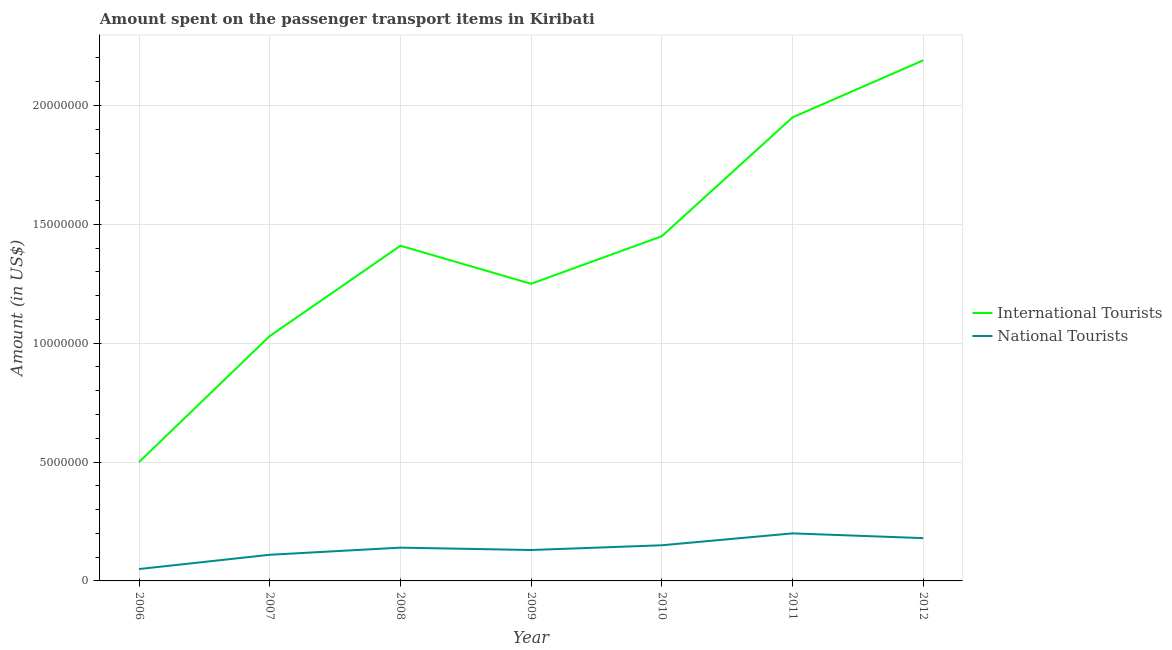What is the amount spent on transport items of international tourists in 2010?
Keep it short and to the point. 1.45e+07. Across all years, what is the maximum amount spent on transport items of international tourists?
Provide a succinct answer. 2.19e+07. Across all years, what is the minimum amount spent on transport items of national tourists?
Keep it short and to the point. 5.00e+05. In which year was the amount spent on transport items of international tourists maximum?
Offer a very short reply. 2012. What is the total amount spent on transport items of international tourists in the graph?
Give a very brief answer. 9.78e+07. What is the difference between the amount spent on transport items of national tourists in 2006 and that in 2008?
Provide a short and direct response. -9.00e+05. What is the difference between the amount spent on transport items of national tourists in 2007 and the amount spent on transport items of international tourists in 2010?
Provide a short and direct response. -1.34e+07. What is the average amount spent on transport items of national tourists per year?
Offer a very short reply. 1.37e+06. In the year 2008, what is the difference between the amount spent on transport items of national tourists and amount spent on transport items of international tourists?
Your response must be concise. -1.27e+07. In how many years, is the amount spent on transport items of national tourists greater than 1000000 US$?
Give a very brief answer. 6. What is the ratio of the amount spent on transport items of international tourists in 2009 to that in 2011?
Keep it short and to the point. 0.64. Is the amount spent on transport items of international tourists in 2006 less than that in 2009?
Make the answer very short. Yes. Is the difference between the amount spent on transport items of international tourists in 2007 and 2010 greater than the difference between the amount spent on transport items of national tourists in 2007 and 2010?
Make the answer very short. No. What is the difference between the highest and the second highest amount spent on transport items of international tourists?
Ensure brevity in your answer.  2.40e+06. What is the difference between the highest and the lowest amount spent on transport items of national tourists?
Give a very brief answer. 1.50e+06. Is the amount spent on transport items of international tourists strictly greater than the amount spent on transport items of national tourists over the years?
Ensure brevity in your answer.  Yes. How many lines are there?
Give a very brief answer. 2. What is the difference between two consecutive major ticks on the Y-axis?
Your answer should be compact. 5.00e+06. Are the values on the major ticks of Y-axis written in scientific E-notation?
Keep it short and to the point. No. Where does the legend appear in the graph?
Offer a terse response. Center right. What is the title of the graph?
Your answer should be compact. Amount spent on the passenger transport items in Kiribati. What is the Amount (in US$) in International Tourists in 2006?
Your answer should be compact. 5.00e+06. What is the Amount (in US$) of National Tourists in 2006?
Provide a short and direct response. 5.00e+05. What is the Amount (in US$) of International Tourists in 2007?
Ensure brevity in your answer.  1.03e+07. What is the Amount (in US$) of National Tourists in 2007?
Offer a very short reply. 1.10e+06. What is the Amount (in US$) in International Tourists in 2008?
Your response must be concise. 1.41e+07. What is the Amount (in US$) of National Tourists in 2008?
Provide a succinct answer. 1.40e+06. What is the Amount (in US$) of International Tourists in 2009?
Give a very brief answer. 1.25e+07. What is the Amount (in US$) of National Tourists in 2009?
Offer a terse response. 1.30e+06. What is the Amount (in US$) of International Tourists in 2010?
Your response must be concise. 1.45e+07. What is the Amount (in US$) in National Tourists in 2010?
Provide a succinct answer. 1.50e+06. What is the Amount (in US$) of International Tourists in 2011?
Ensure brevity in your answer.  1.95e+07. What is the Amount (in US$) of National Tourists in 2011?
Offer a very short reply. 2.00e+06. What is the Amount (in US$) of International Tourists in 2012?
Offer a terse response. 2.19e+07. What is the Amount (in US$) of National Tourists in 2012?
Your answer should be compact. 1.80e+06. Across all years, what is the maximum Amount (in US$) in International Tourists?
Provide a short and direct response. 2.19e+07. Across all years, what is the minimum Amount (in US$) of International Tourists?
Offer a very short reply. 5.00e+06. What is the total Amount (in US$) of International Tourists in the graph?
Offer a very short reply. 9.78e+07. What is the total Amount (in US$) in National Tourists in the graph?
Give a very brief answer. 9.60e+06. What is the difference between the Amount (in US$) in International Tourists in 2006 and that in 2007?
Your response must be concise. -5.30e+06. What is the difference between the Amount (in US$) of National Tourists in 2006 and that in 2007?
Provide a short and direct response. -6.00e+05. What is the difference between the Amount (in US$) of International Tourists in 2006 and that in 2008?
Offer a terse response. -9.10e+06. What is the difference between the Amount (in US$) in National Tourists in 2006 and that in 2008?
Make the answer very short. -9.00e+05. What is the difference between the Amount (in US$) of International Tourists in 2006 and that in 2009?
Keep it short and to the point. -7.50e+06. What is the difference between the Amount (in US$) of National Tourists in 2006 and that in 2009?
Offer a very short reply. -8.00e+05. What is the difference between the Amount (in US$) of International Tourists in 2006 and that in 2010?
Make the answer very short. -9.50e+06. What is the difference between the Amount (in US$) of National Tourists in 2006 and that in 2010?
Offer a terse response. -1.00e+06. What is the difference between the Amount (in US$) of International Tourists in 2006 and that in 2011?
Your answer should be compact. -1.45e+07. What is the difference between the Amount (in US$) in National Tourists in 2006 and that in 2011?
Ensure brevity in your answer.  -1.50e+06. What is the difference between the Amount (in US$) of International Tourists in 2006 and that in 2012?
Ensure brevity in your answer.  -1.69e+07. What is the difference between the Amount (in US$) of National Tourists in 2006 and that in 2012?
Your response must be concise. -1.30e+06. What is the difference between the Amount (in US$) in International Tourists in 2007 and that in 2008?
Offer a terse response. -3.80e+06. What is the difference between the Amount (in US$) in International Tourists in 2007 and that in 2009?
Offer a terse response. -2.20e+06. What is the difference between the Amount (in US$) in International Tourists in 2007 and that in 2010?
Your answer should be very brief. -4.20e+06. What is the difference between the Amount (in US$) of National Tourists in 2007 and that in 2010?
Offer a very short reply. -4.00e+05. What is the difference between the Amount (in US$) of International Tourists in 2007 and that in 2011?
Your response must be concise. -9.20e+06. What is the difference between the Amount (in US$) in National Tourists in 2007 and that in 2011?
Provide a short and direct response. -9.00e+05. What is the difference between the Amount (in US$) of International Tourists in 2007 and that in 2012?
Make the answer very short. -1.16e+07. What is the difference between the Amount (in US$) in National Tourists in 2007 and that in 2012?
Offer a very short reply. -7.00e+05. What is the difference between the Amount (in US$) in International Tourists in 2008 and that in 2009?
Provide a succinct answer. 1.60e+06. What is the difference between the Amount (in US$) of International Tourists in 2008 and that in 2010?
Your answer should be compact. -4.00e+05. What is the difference between the Amount (in US$) in National Tourists in 2008 and that in 2010?
Offer a terse response. -1.00e+05. What is the difference between the Amount (in US$) of International Tourists in 2008 and that in 2011?
Offer a very short reply. -5.40e+06. What is the difference between the Amount (in US$) of National Tourists in 2008 and that in 2011?
Provide a succinct answer. -6.00e+05. What is the difference between the Amount (in US$) in International Tourists in 2008 and that in 2012?
Ensure brevity in your answer.  -7.80e+06. What is the difference between the Amount (in US$) of National Tourists in 2008 and that in 2012?
Offer a terse response. -4.00e+05. What is the difference between the Amount (in US$) of National Tourists in 2009 and that in 2010?
Make the answer very short. -2.00e+05. What is the difference between the Amount (in US$) in International Tourists in 2009 and that in 2011?
Give a very brief answer. -7.00e+06. What is the difference between the Amount (in US$) of National Tourists in 2009 and that in 2011?
Your answer should be compact. -7.00e+05. What is the difference between the Amount (in US$) in International Tourists in 2009 and that in 2012?
Give a very brief answer. -9.40e+06. What is the difference between the Amount (in US$) of National Tourists in 2009 and that in 2012?
Give a very brief answer. -5.00e+05. What is the difference between the Amount (in US$) in International Tourists in 2010 and that in 2011?
Offer a very short reply. -5.00e+06. What is the difference between the Amount (in US$) in National Tourists in 2010 and that in 2011?
Give a very brief answer. -5.00e+05. What is the difference between the Amount (in US$) in International Tourists in 2010 and that in 2012?
Provide a short and direct response. -7.40e+06. What is the difference between the Amount (in US$) of National Tourists in 2010 and that in 2012?
Your answer should be compact. -3.00e+05. What is the difference between the Amount (in US$) of International Tourists in 2011 and that in 2012?
Keep it short and to the point. -2.40e+06. What is the difference between the Amount (in US$) of International Tourists in 2006 and the Amount (in US$) of National Tourists in 2007?
Ensure brevity in your answer.  3.90e+06. What is the difference between the Amount (in US$) in International Tourists in 2006 and the Amount (in US$) in National Tourists in 2008?
Give a very brief answer. 3.60e+06. What is the difference between the Amount (in US$) of International Tourists in 2006 and the Amount (in US$) of National Tourists in 2009?
Keep it short and to the point. 3.70e+06. What is the difference between the Amount (in US$) in International Tourists in 2006 and the Amount (in US$) in National Tourists in 2010?
Your answer should be compact. 3.50e+06. What is the difference between the Amount (in US$) in International Tourists in 2006 and the Amount (in US$) in National Tourists in 2012?
Your response must be concise. 3.20e+06. What is the difference between the Amount (in US$) of International Tourists in 2007 and the Amount (in US$) of National Tourists in 2008?
Ensure brevity in your answer.  8.90e+06. What is the difference between the Amount (in US$) in International Tourists in 2007 and the Amount (in US$) in National Tourists in 2009?
Provide a short and direct response. 9.00e+06. What is the difference between the Amount (in US$) of International Tourists in 2007 and the Amount (in US$) of National Tourists in 2010?
Provide a short and direct response. 8.80e+06. What is the difference between the Amount (in US$) of International Tourists in 2007 and the Amount (in US$) of National Tourists in 2011?
Your answer should be compact. 8.30e+06. What is the difference between the Amount (in US$) of International Tourists in 2007 and the Amount (in US$) of National Tourists in 2012?
Ensure brevity in your answer.  8.50e+06. What is the difference between the Amount (in US$) of International Tourists in 2008 and the Amount (in US$) of National Tourists in 2009?
Your answer should be very brief. 1.28e+07. What is the difference between the Amount (in US$) of International Tourists in 2008 and the Amount (in US$) of National Tourists in 2010?
Provide a succinct answer. 1.26e+07. What is the difference between the Amount (in US$) of International Tourists in 2008 and the Amount (in US$) of National Tourists in 2011?
Make the answer very short. 1.21e+07. What is the difference between the Amount (in US$) in International Tourists in 2008 and the Amount (in US$) in National Tourists in 2012?
Give a very brief answer. 1.23e+07. What is the difference between the Amount (in US$) of International Tourists in 2009 and the Amount (in US$) of National Tourists in 2010?
Offer a terse response. 1.10e+07. What is the difference between the Amount (in US$) of International Tourists in 2009 and the Amount (in US$) of National Tourists in 2011?
Provide a short and direct response. 1.05e+07. What is the difference between the Amount (in US$) of International Tourists in 2009 and the Amount (in US$) of National Tourists in 2012?
Offer a terse response. 1.07e+07. What is the difference between the Amount (in US$) in International Tourists in 2010 and the Amount (in US$) in National Tourists in 2011?
Make the answer very short. 1.25e+07. What is the difference between the Amount (in US$) of International Tourists in 2010 and the Amount (in US$) of National Tourists in 2012?
Your answer should be very brief. 1.27e+07. What is the difference between the Amount (in US$) in International Tourists in 2011 and the Amount (in US$) in National Tourists in 2012?
Provide a succinct answer. 1.77e+07. What is the average Amount (in US$) of International Tourists per year?
Your response must be concise. 1.40e+07. What is the average Amount (in US$) in National Tourists per year?
Give a very brief answer. 1.37e+06. In the year 2006, what is the difference between the Amount (in US$) in International Tourists and Amount (in US$) in National Tourists?
Offer a very short reply. 4.50e+06. In the year 2007, what is the difference between the Amount (in US$) of International Tourists and Amount (in US$) of National Tourists?
Offer a very short reply. 9.20e+06. In the year 2008, what is the difference between the Amount (in US$) in International Tourists and Amount (in US$) in National Tourists?
Offer a very short reply. 1.27e+07. In the year 2009, what is the difference between the Amount (in US$) in International Tourists and Amount (in US$) in National Tourists?
Give a very brief answer. 1.12e+07. In the year 2010, what is the difference between the Amount (in US$) in International Tourists and Amount (in US$) in National Tourists?
Your response must be concise. 1.30e+07. In the year 2011, what is the difference between the Amount (in US$) of International Tourists and Amount (in US$) of National Tourists?
Provide a succinct answer. 1.75e+07. In the year 2012, what is the difference between the Amount (in US$) of International Tourists and Amount (in US$) of National Tourists?
Your answer should be compact. 2.01e+07. What is the ratio of the Amount (in US$) in International Tourists in 2006 to that in 2007?
Provide a short and direct response. 0.49. What is the ratio of the Amount (in US$) of National Tourists in 2006 to that in 2007?
Offer a terse response. 0.45. What is the ratio of the Amount (in US$) in International Tourists in 2006 to that in 2008?
Ensure brevity in your answer.  0.35. What is the ratio of the Amount (in US$) of National Tourists in 2006 to that in 2008?
Make the answer very short. 0.36. What is the ratio of the Amount (in US$) in International Tourists in 2006 to that in 2009?
Provide a short and direct response. 0.4. What is the ratio of the Amount (in US$) in National Tourists in 2006 to that in 2009?
Provide a succinct answer. 0.38. What is the ratio of the Amount (in US$) in International Tourists in 2006 to that in 2010?
Provide a succinct answer. 0.34. What is the ratio of the Amount (in US$) of National Tourists in 2006 to that in 2010?
Your answer should be very brief. 0.33. What is the ratio of the Amount (in US$) of International Tourists in 2006 to that in 2011?
Ensure brevity in your answer.  0.26. What is the ratio of the Amount (in US$) in International Tourists in 2006 to that in 2012?
Make the answer very short. 0.23. What is the ratio of the Amount (in US$) of National Tourists in 2006 to that in 2012?
Provide a succinct answer. 0.28. What is the ratio of the Amount (in US$) of International Tourists in 2007 to that in 2008?
Your answer should be compact. 0.73. What is the ratio of the Amount (in US$) in National Tourists in 2007 to that in 2008?
Offer a terse response. 0.79. What is the ratio of the Amount (in US$) in International Tourists in 2007 to that in 2009?
Make the answer very short. 0.82. What is the ratio of the Amount (in US$) of National Tourists in 2007 to that in 2009?
Give a very brief answer. 0.85. What is the ratio of the Amount (in US$) of International Tourists in 2007 to that in 2010?
Your response must be concise. 0.71. What is the ratio of the Amount (in US$) of National Tourists in 2007 to that in 2010?
Provide a short and direct response. 0.73. What is the ratio of the Amount (in US$) in International Tourists in 2007 to that in 2011?
Provide a succinct answer. 0.53. What is the ratio of the Amount (in US$) of National Tourists in 2007 to that in 2011?
Offer a terse response. 0.55. What is the ratio of the Amount (in US$) of International Tourists in 2007 to that in 2012?
Your answer should be compact. 0.47. What is the ratio of the Amount (in US$) in National Tourists in 2007 to that in 2012?
Your answer should be very brief. 0.61. What is the ratio of the Amount (in US$) in International Tourists in 2008 to that in 2009?
Provide a succinct answer. 1.13. What is the ratio of the Amount (in US$) of National Tourists in 2008 to that in 2009?
Keep it short and to the point. 1.08. What is the ratio of the Amount (in US$) of International Tourists in 2008 to that in 2010?
Give a very brief answer. 0.97. What is the ratio of the Amount (in US$) in National Tourists in 2008 to that in 2010?
Offer a terse response. 0.93. What is the ratio of the Amount (in US$) in International Tourists in 2008 to that in 2011?
Your response must be concise. 0.72. What is the ratio of the Amount (in US$) of National Tourists in 2008 to that in 2011?
Your response must be concise. 0.7. What is the ratio of the Amount (in US$) of International Tourists in 2008 to that in 2012?
Make the answer very short. 0.64. What is the ratio of the Amount (in US$) of National Tourists in 2008 to that in 2012?
Your answer should be very brief. 0.78. What is the ratio of the Amount (in US$) in International Tourists in 2009 to that in 2010?
Offer a terse response. 0.86. What is the ratio of the Amount (in US$) in National Tourists in 2009 to that in 2010?
Offer a terse response. 0.87. What is the ratio of the Amount (in US$) of International Tourists in 2009 to that in 2011?
Keep it short and to the point. 0.64. What is the ratio of the Amount (in US$) of National Tourists in 2009 to that in 2011?
Offer a very short reply. 0.65. What is the ratio of the Amount (in US$) of International Tourists in 2009 to that in 2012?
Offer a terse response. 0.57. What is the ratio of the Amount (in US$) in National Tourists in 2009 to that in 2012?
Provide a succinct answer. 0.72. What is the ratio of the Amount (in US$) of International Tourists in 2010 to that in 2011?
Offer a very short reply. 0.74. What is the ratio of the Amount (in US$) in International Tourists in 2010 to that in 2012?
Keep it short and to the point. 0.66. What is the ratio of the Amount (in US$) in International Tourists in 2011 to that in 2012?
Your response must be concise. 0.89. What is the ratio of the Amount (in US$) in National Tourists in 2011 to that in 2012?
Offer a very short reply. 1.11. What is the difference between the highest and the second highest Amount (in US$) of International Tourists?
Ensure brevity in your answer.  2.40e+06. What is the difference between the highest and the second highest Amount (in US$) of National Tourists?
Offer a terse response. 2.00e+05. What is the difference between the highest and the lowest Amount (in US$) of International Tourists?
Make the answer very short. 1.69e+07. What is the difference between the highest and the lowest Amount (in US$) of National Tourists?
Your answer should be compact. 1.50e+06. 